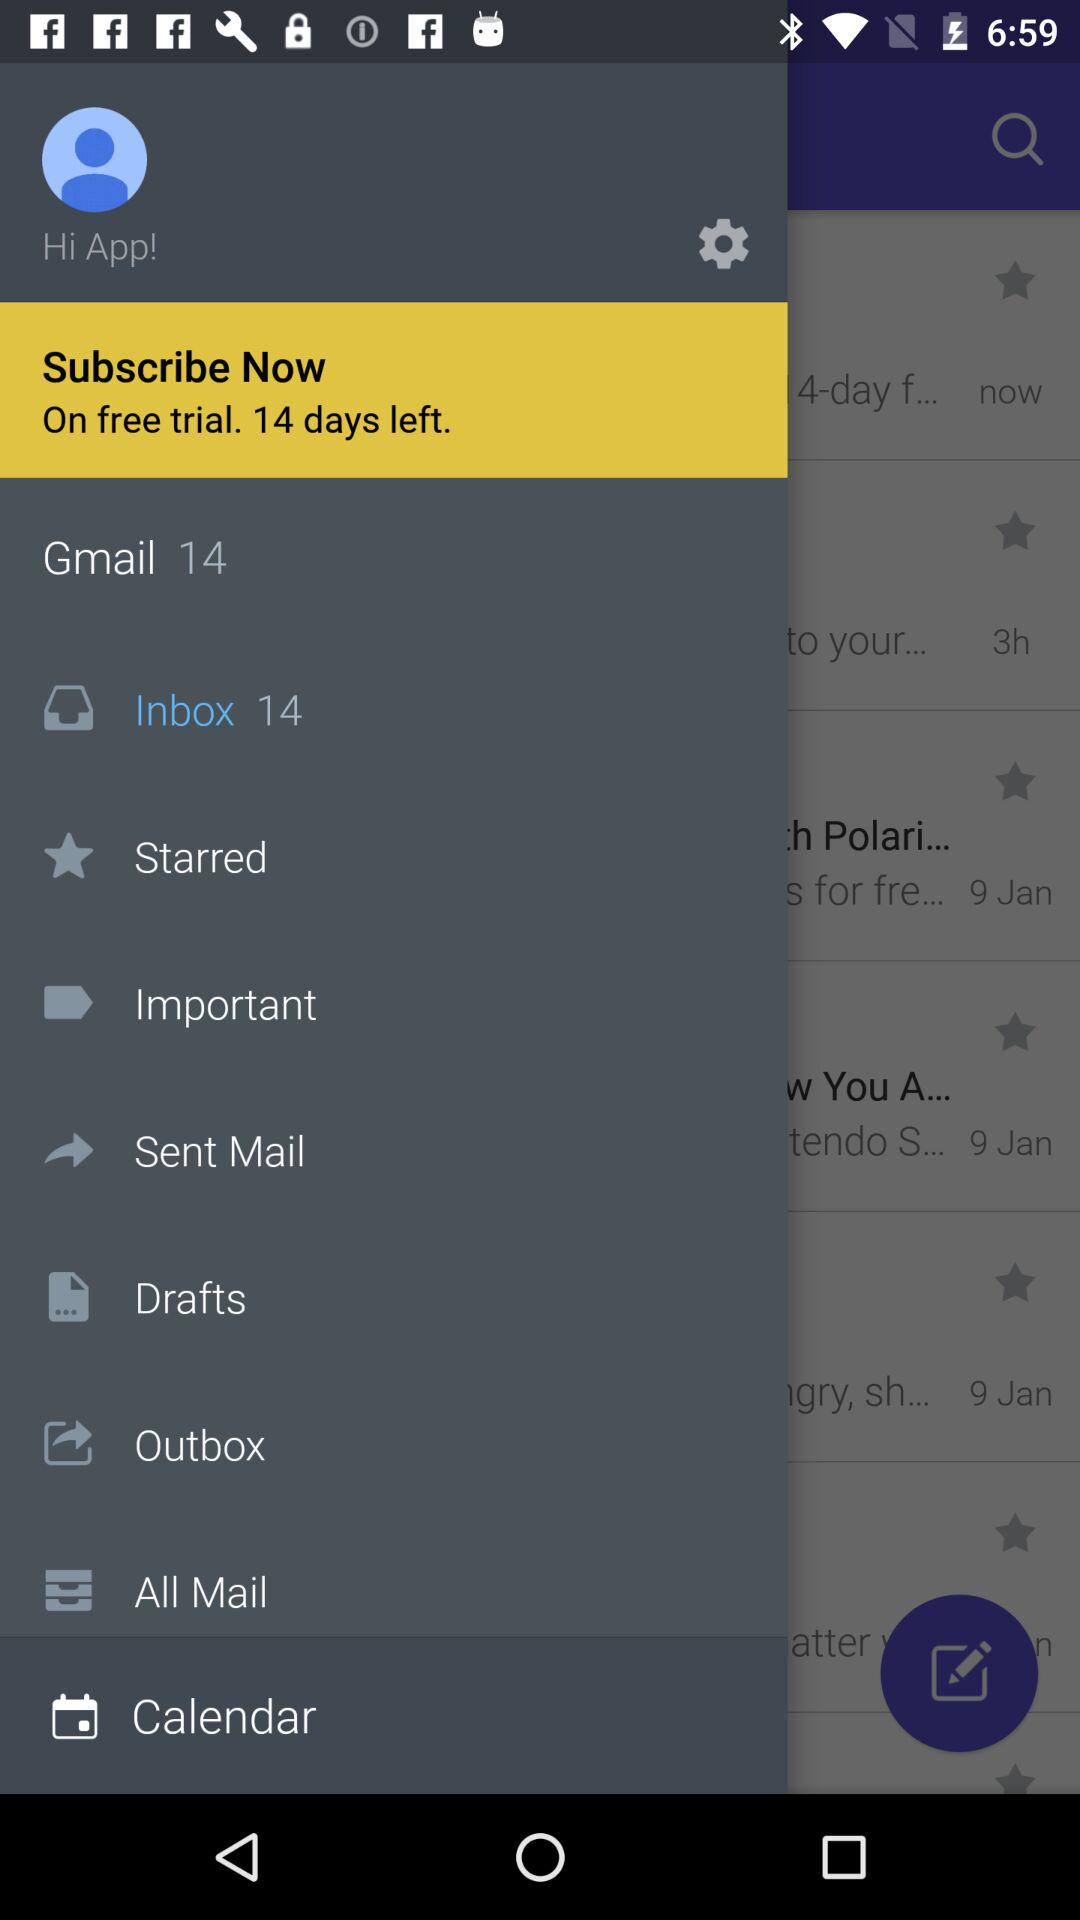How many days are left on the free trial?
Answer the question using a single word or phrase. 14 